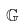Convert formula to latex. <formula><loc_0><loc_0><loc_500><loc_500>\mathbb { G }</formula> 